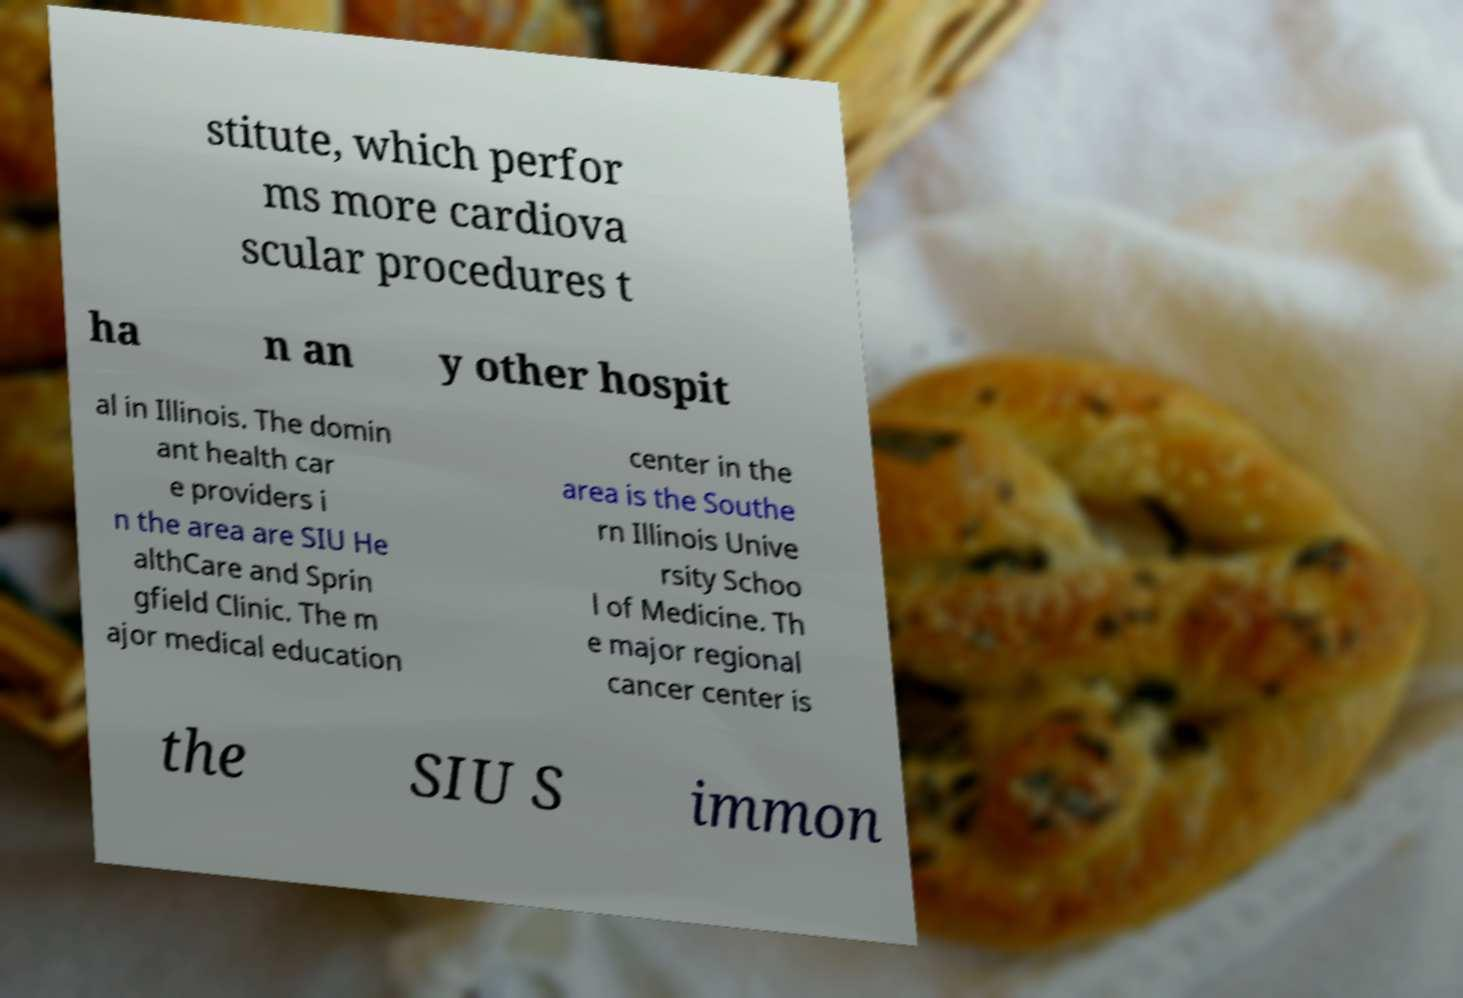What messages or text are displayed in this image? I need them in a readable, typed format. stitute, which perfor ms more cardiova scular procedures t ha n an y other hospit al in Illinois. The domin ant health car e providers i n the area are SIU He althCare and Sprin gfield Clinic. The m ajor medical education center in the area is the Southe rn Illinois Unive rsity Schoo l of Medicine. Th e major regional cancer center is the SIU S immon 